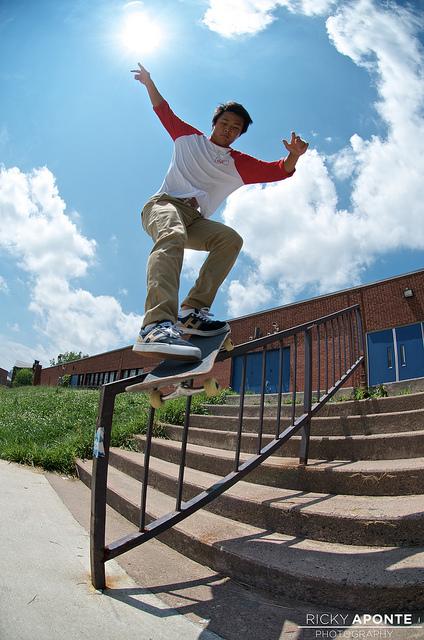What is the boy skating on?
Concise answer only. Rail. What color are the boy's shoes?
Be succinct. Blue. What color are the man's pants?
Answer briefly. Tan. What is this person doing?
Keep it brief. Skateboarding. Is the man young or older?
Concise answer only. Young. 